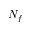Convert formula to latex. <formula><loc_0><loc_0><loc_500><loc_500>N _ { f }</formula> 